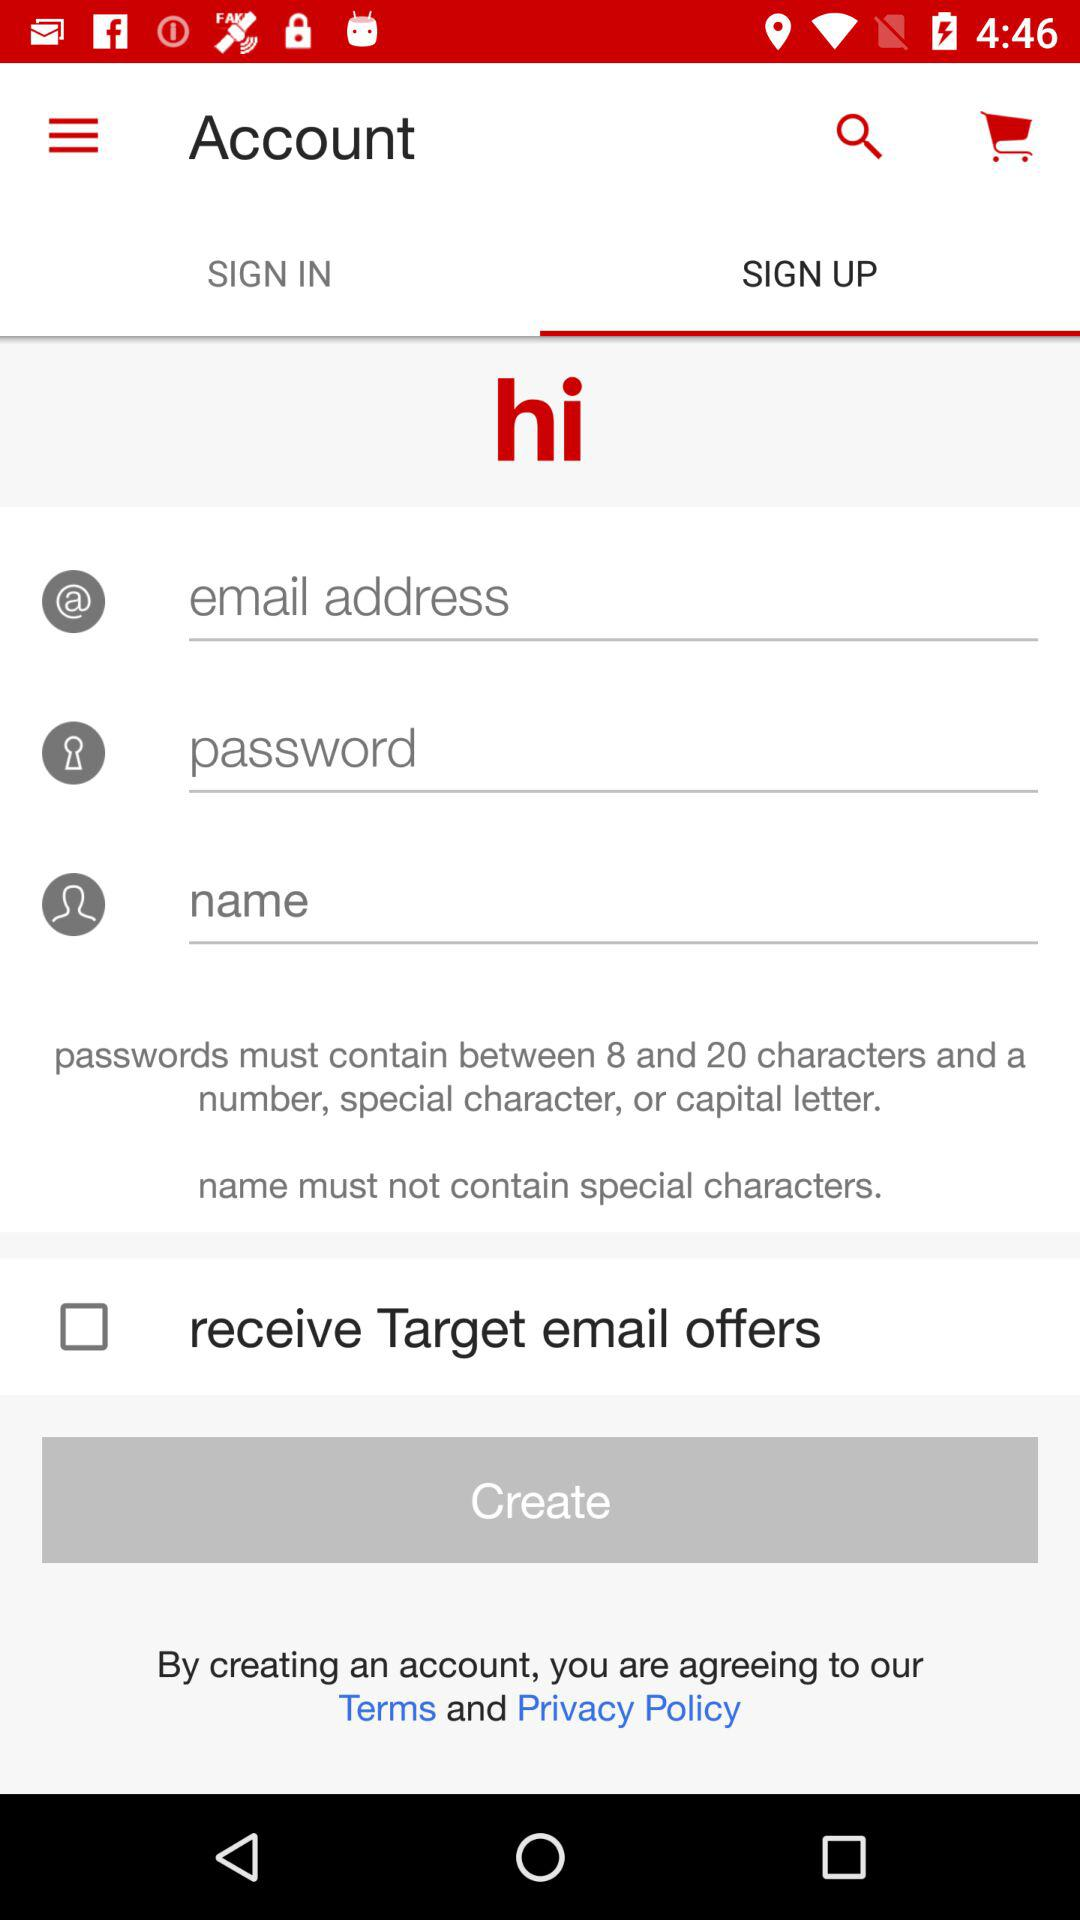How many text inputs are required to create an account?
Answer the question using a single word or phrase. 3 